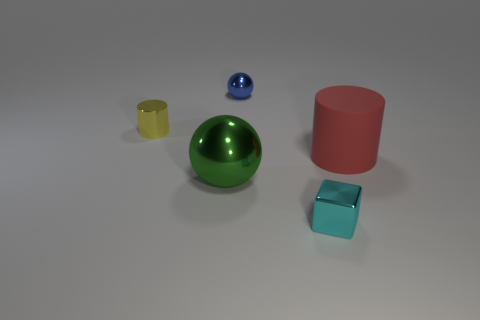Add 2 tiny cubes. How many objects exist? 7 Subtract all spheres. How many objects are left? 3 Add 1 large matte cylinders. How many large matte cylinders are left? 2 Add 5 cyan metal cubes. How many cyan metal cubes exist? 6 Subtract 0 yellow cubes. How many objects are left? 5 Subtract all big metal cylinders. Subtract all big red cylinders. How many objects are left? 4 